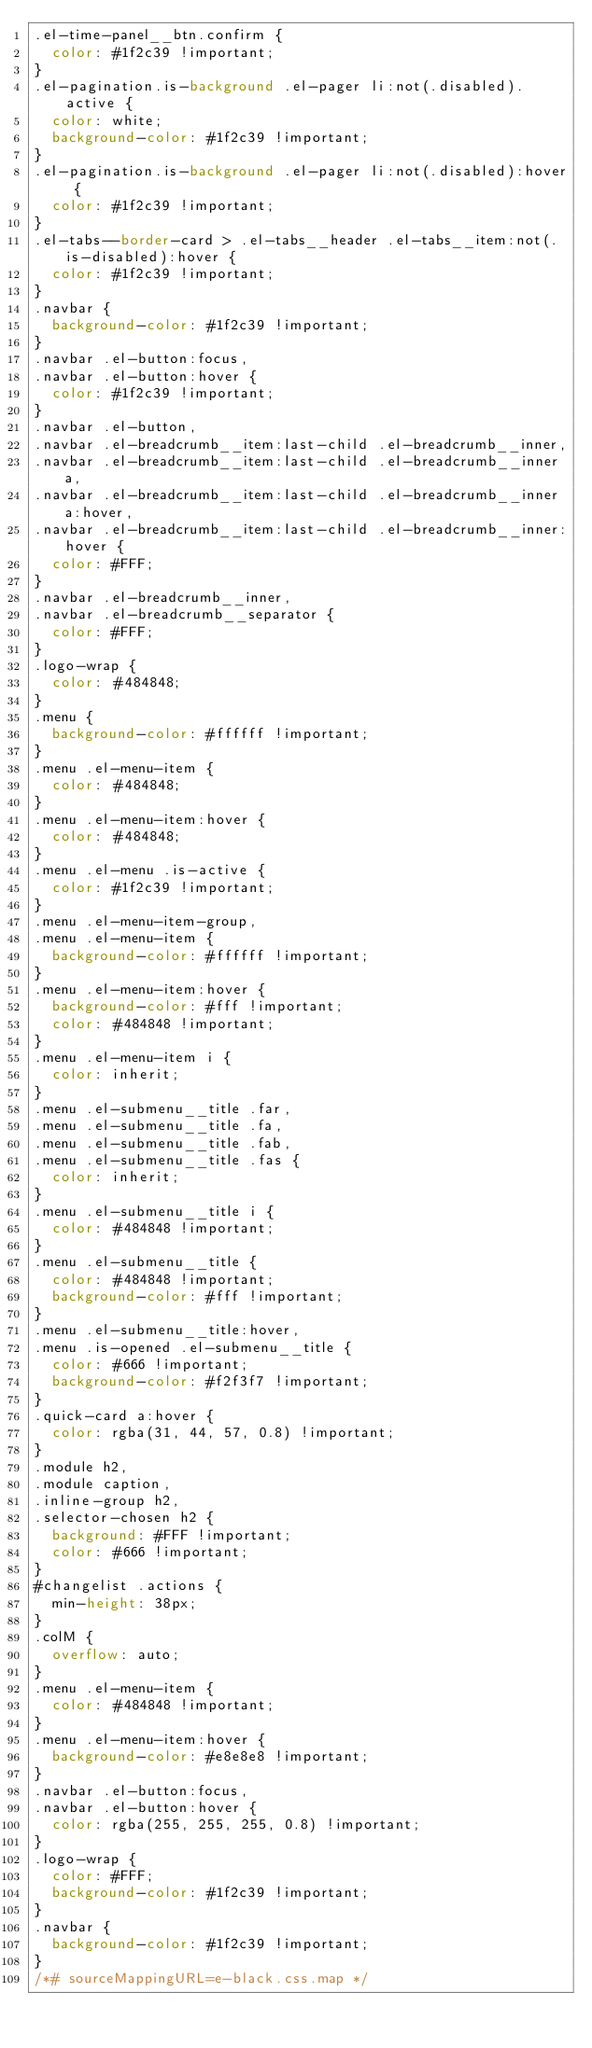Convert code to text. <code><loc_0><loc_0><loc_500><loc_500><_CSS_>.el-time-panel__btn.confirm {
  color: #1f2c39 !important;
}
.el-pagination.is-background .el-pager li:not(.disabled).active {
  color: white;
  background-color: #1f2c39 !important;
}
.el-pagination.is-background .el-pager li:not(.disabled):hover {
  color: #1f2c39 !important;
}
.el-tabs--border-card > .el-tabs__header .el-tabs__item:not(.is-disabled):hover {
  color: #1f2c39 !important;
}
.navbar {
  background-color: #1f2c39 !important;
}
.navbar .el-button:focus,
.navbar .el-button:hover {
  color: #1f2c39 !important;
}
.navbar .el-button,
.navbar .el-breadcrumb__item:last-child .el-breadcrumb__inner,
.navbar .el-breadcrumb__item:last-child .el-breadcrumb__inner a,
.navbar .el-breadcrumb__item:last-child .el-breadcrumb__inner a:hover,
.navbar .el-breadcrumb__item:last-child .el-breadcrumb__inner:hover {
  color: #FFF;
}
.navbar .el-breadcrumb__inner,
.navbar .el-breadcrumb__separator {
  color: #FFF;
}
.logo-wrap {
  color: #484848;
}
.menu {
  background-color: #ffffff !important;
}
.menu .el-menu-item {
  color: #484848;
}
.menu .el-menu-item:hover {
  color: #484848;
}
.menu .el-menu .is-active {
  color: #1f2c39 !important;
}
.menu .el-menu-item-group,
.menu .el-menu-item {
  background-color: #ffffff !important;
}
.menu .el-menu-item:hover {
  background-color: #fff !important;
  color: #484848 !important;
}
.menu .el-menu-item i {
  color: inherit;
}
.menu .el-submenu__title .far,
.menu .el-submenu__title .fa,
.menu .el-submenu__title .fab,
.menu .el-submenu__title .fas {
  color: inherit;
}
.menu .el-submenu__title i {
  color: #484848 !important;
}
.menu .el-submenu__title {
  color: #484848 !important;
  background-color: #fff !important;
}
.menu .el-submenu__title:hover,
.menu .is-opened .el-submenu__title {
  color: #666 !important;
  background-color: #f2f3f7 !important;
}
.quick-card a:hover {
  color: rgba(31, 44, 57, 0.8) !important;
}
.module h2,
.module caption,
.inline-group h2,
.selector-chosen h2 {
  background: #FFF !important;
  color: #666 !important;
}
#changelist .actions {
  min-height: 38px;
}
.colM {
  overflow: auto;
}
.menu .el-menu-item {
  color: #484848 !important;
}
.menu .el-menu-item:hover {
  background-color: #e8e8e8 !important;
}
.navbar .el-button:focus,
.navbar .el-button:hover {
  color: rgba(255, 255, 255, 0.8) !important;
}
.logo-wrap {
  color: #FFF;
  background-color: #1f2c39 !important;
}
.navbar {
  background-color: #1f2c39 !important;
}
/*# sourceMappingURL=e-black.css.map */</code> 